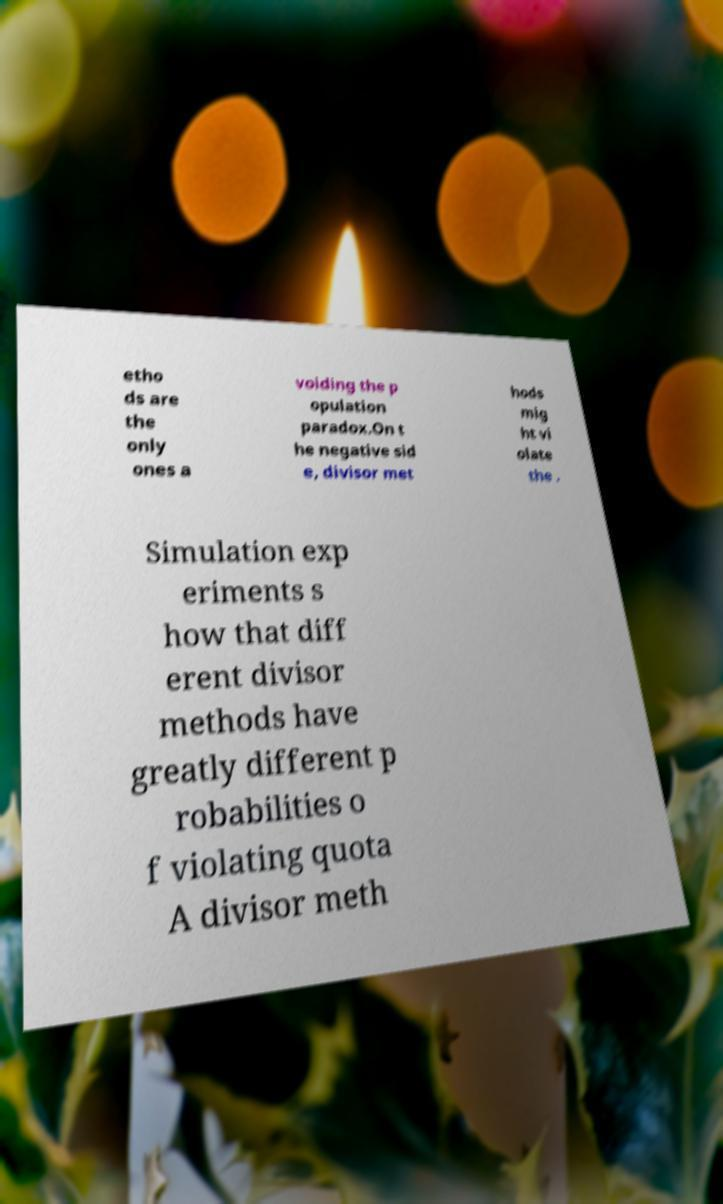What messages or text are displayed in this image? I need them in a readable, typed format. etho ds are the only ones a voiding the p opulation paradox.On t he negative sid e, divisor met hods mig ht vi olate the . Simulation exp eriments s how that diff erent divisor methods have greatly different p robabilities o f violating quota A divisor meth 